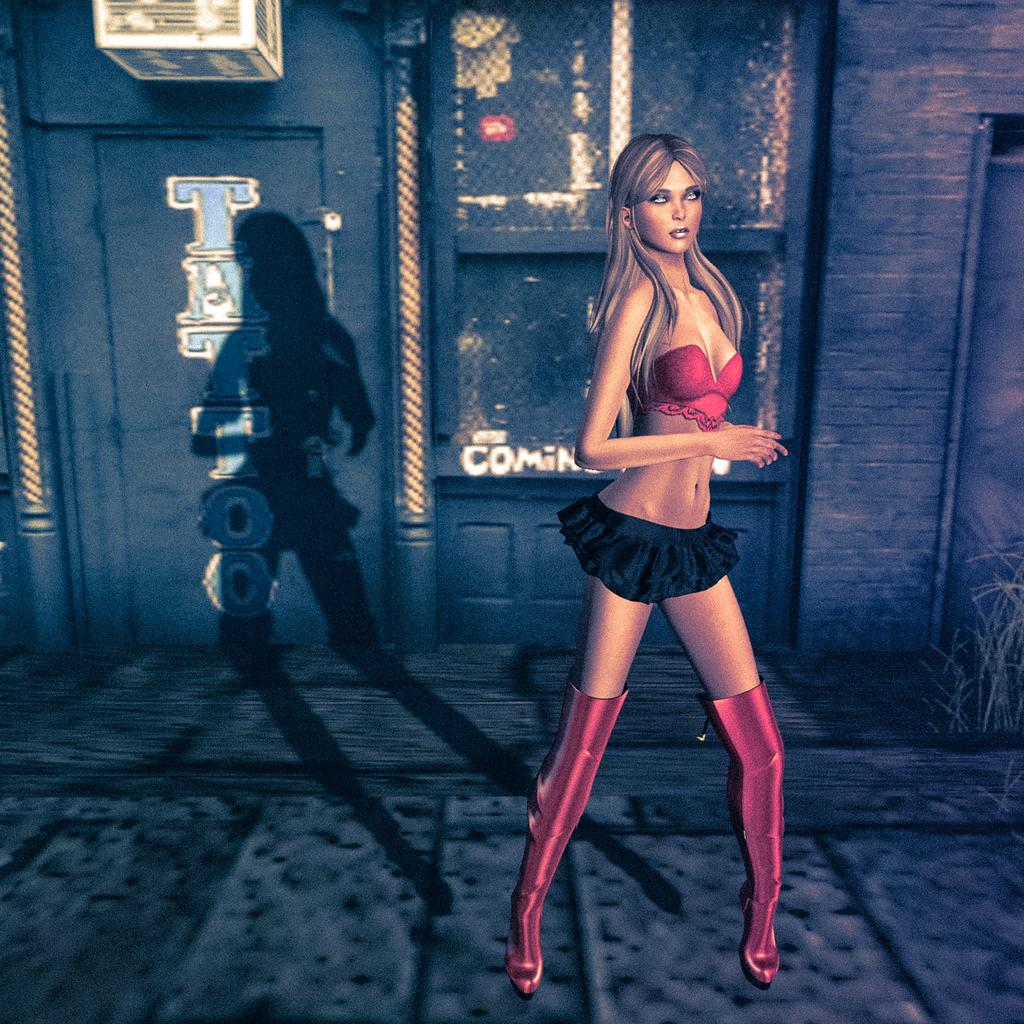What type of character is in the picture? There is an animated woman in the picture. What can be seen in the background of the picture? There is a wall in the background of the picture, and a shadow of a woman. What is written on the wall? There is a name on the wall. What color is the object in the picture? There is a white color object in the picture. How long does it take for the animated woman to stamp the minute in the image? There is no stamp or minute present in the image, so it's not possible to answer that question. 